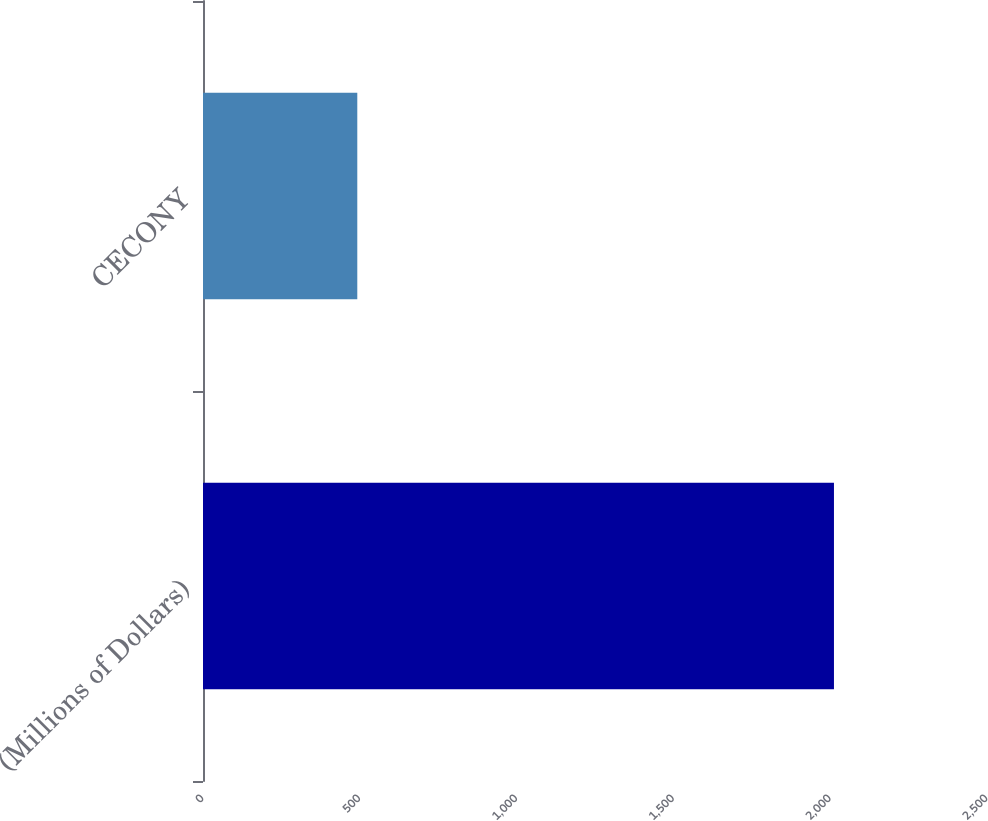Convert chart. <chart><loc_0><loc_0><loc_500><loc_500><bar_chart><fcel>(Millions of Dollars)<fcel>CECONY<nl><fcel>2012<fcel>492<nl></chart> 